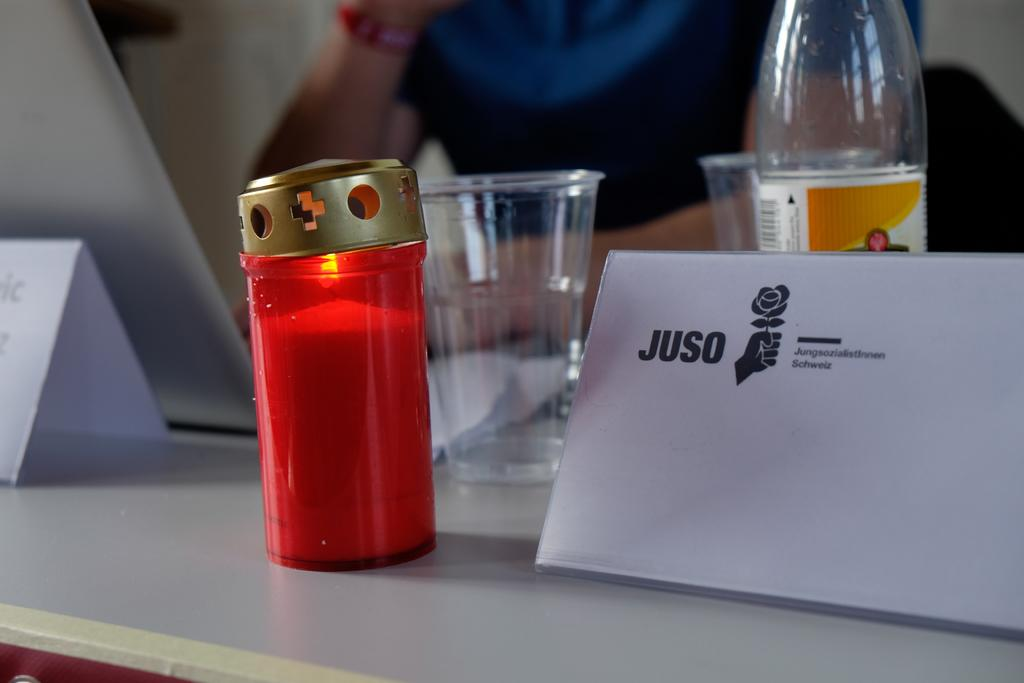<image>
Write a terse but informative summary of the picture. A candle sits alight on a small table at a conference 